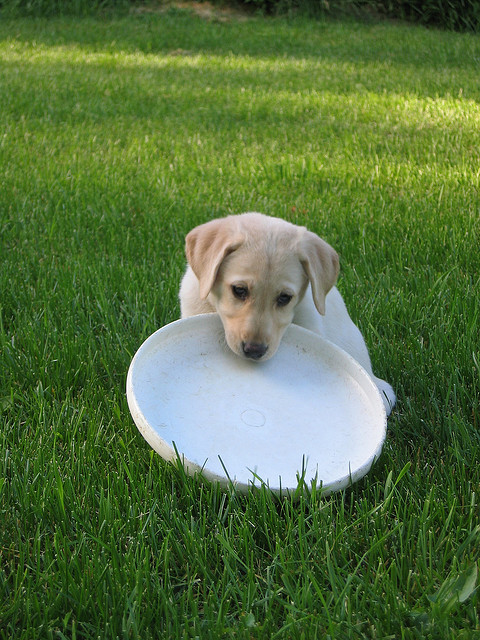Does a woman throw the Frisbee? Based on the image, it is actually a dog that is seen with the Frisbee in its mouth, and there is no visible action of a woman throwing the Frisbee. 